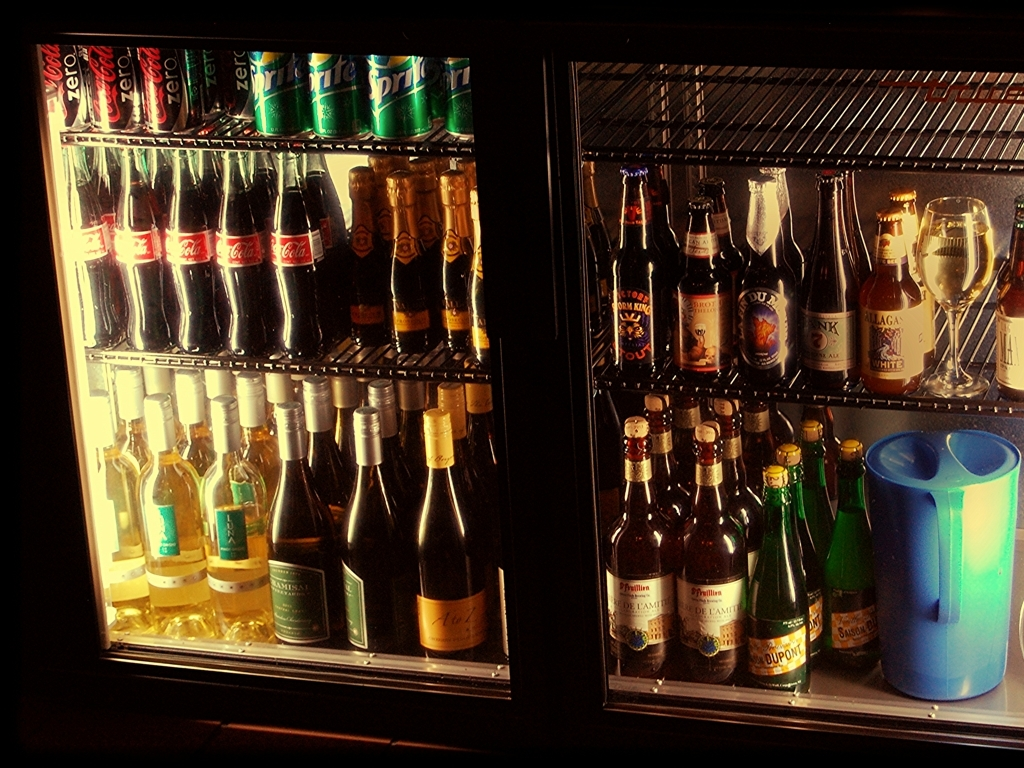Are the details of the main subject rich in texture?
A. Yes
B. No
Answer with the option's letter from the given choices directly.
 A. 